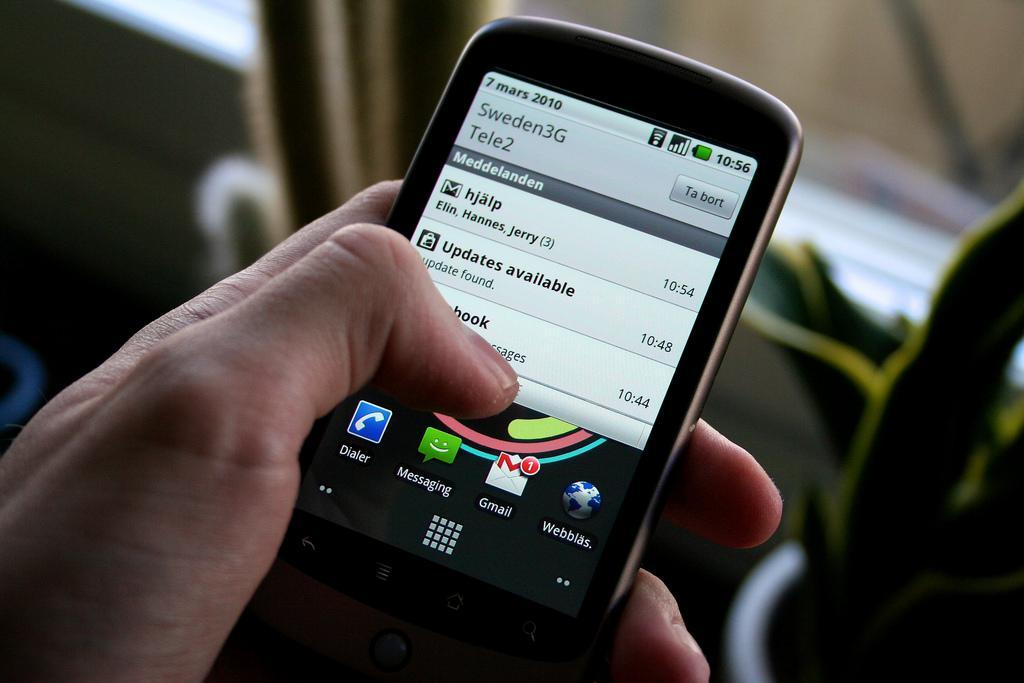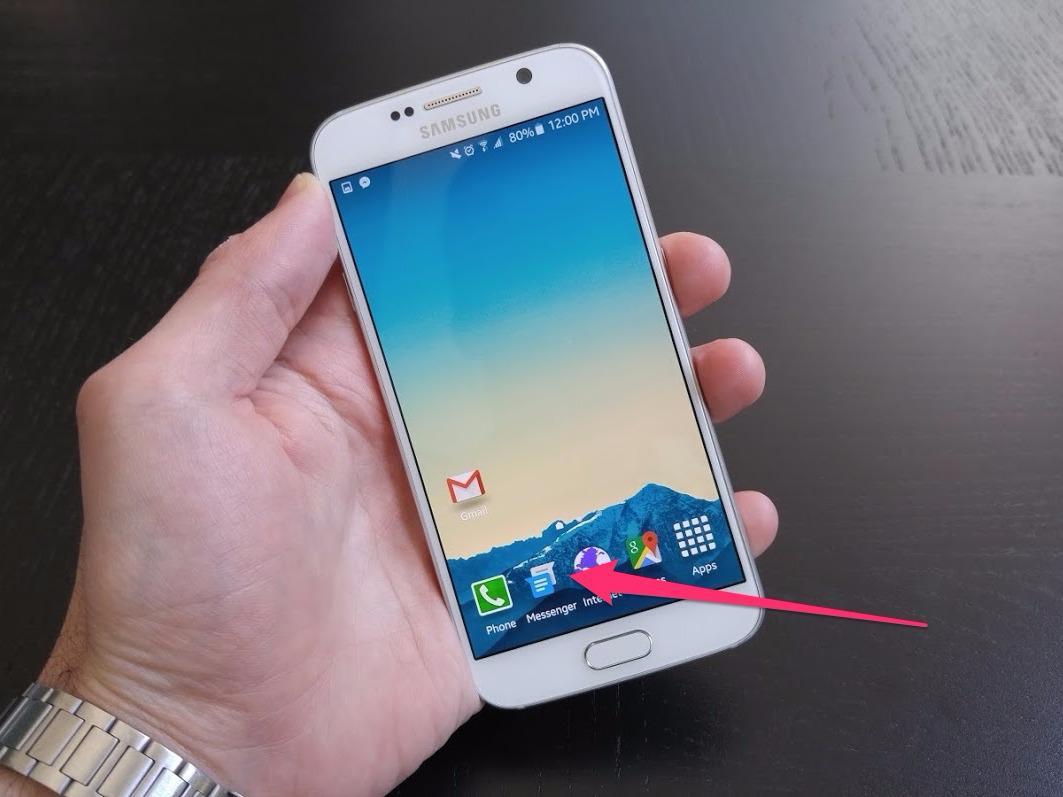The first image is the image on the left, the second image is the image on the right. Examine the images to the left and right. Is the description "A person is holding the phone in at least one of the images." accurate? Answer yes or no. Yes. The first image is the image on the left, the second image is the image on the right. Analyze the images presented: Is the assertion "A thumb is pressing the phone's screen in the image on the left." valid? Answer yes or no. Yes. 